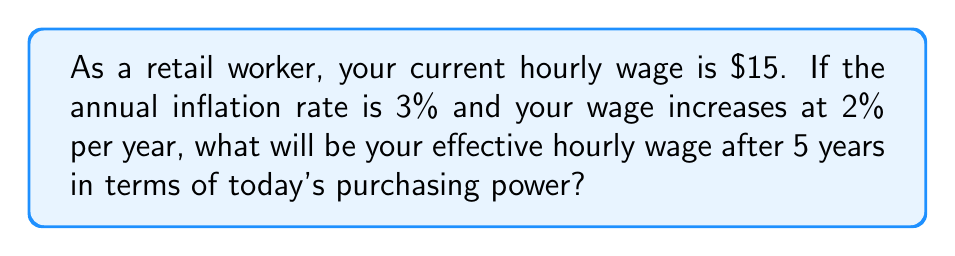Give your solution to this math problem. Let's approach this step-by-step:

1) First, we need to calculate the nominal wage after 5 years with a 2% annual increase:
   $$W_5 = 15 \cdot (1.02)^5 = 15 \cdot 1.1041 = 16.56$$

2) Now, we need to account for inflation. The purchasing power of money decreases with inflation. We can calculate this using the compound interest formula:
   $$P_5 = (1 + 0.03)^5 = 1.1593$$

   This means that what costs $1 today will cost $1.1593 in 5 years.

3) To find the effective wage in today's purchasing power, we divide the nominal wage by the inflation factor:
   $$\text{Effective Wage} = \frac{W_5}{P_5} = \frac{16.56}{1.1593} = 14.28$$

Therefore, although your nominal wage increases to $16.56, its purchasing power is equivalent to $14.28 in today's terms.
Answer: $14.28 